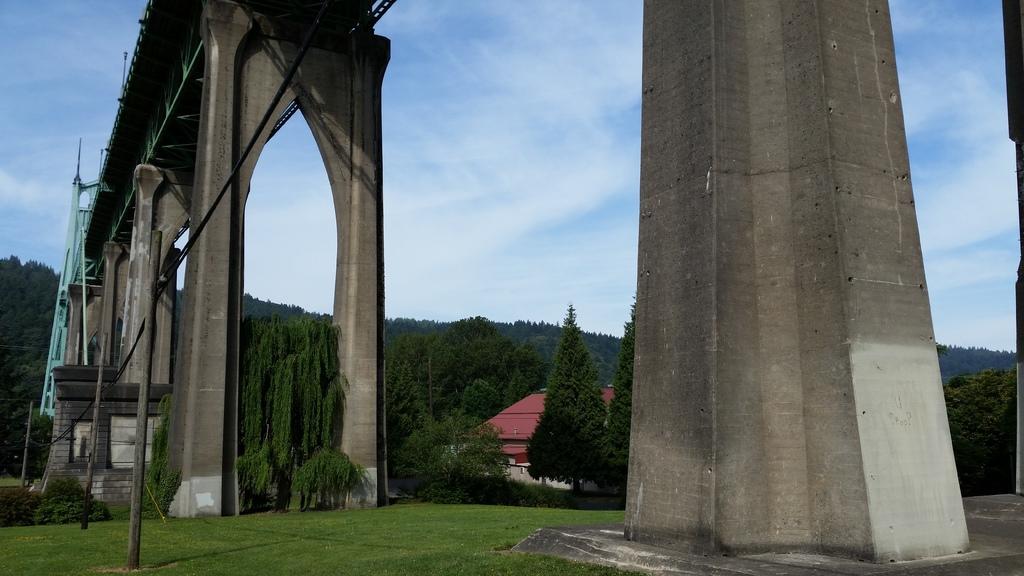In one or two sentences, can you explain what this image depicts? In this image we can see a bridge with metal poles and the pillars. We can also see the grass, a group of trees, a house, wires and the sky which looks cloudy. 